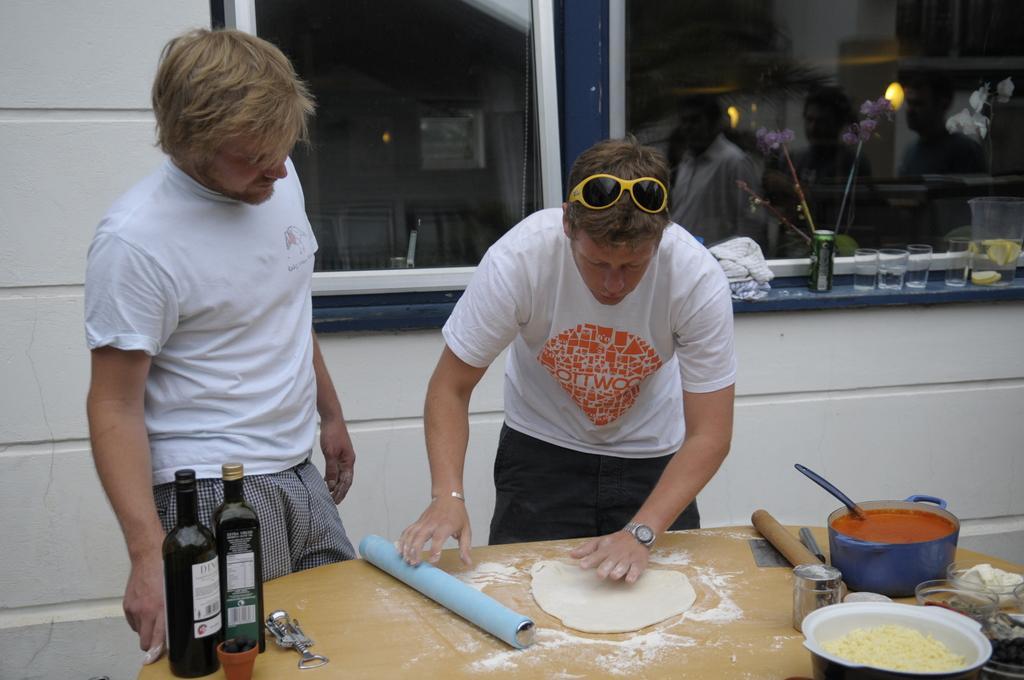In one or two sentences, can you explain what this image depicts? In this image, we can see two people are standing near the table. Here we can see few objects, bottles, cooking pot, containers on the table. Background there is a wall, glass windows. On the glass we can see some reflections. Here we can see few people. On the right side of the image, we can see in, glasses and few things. 